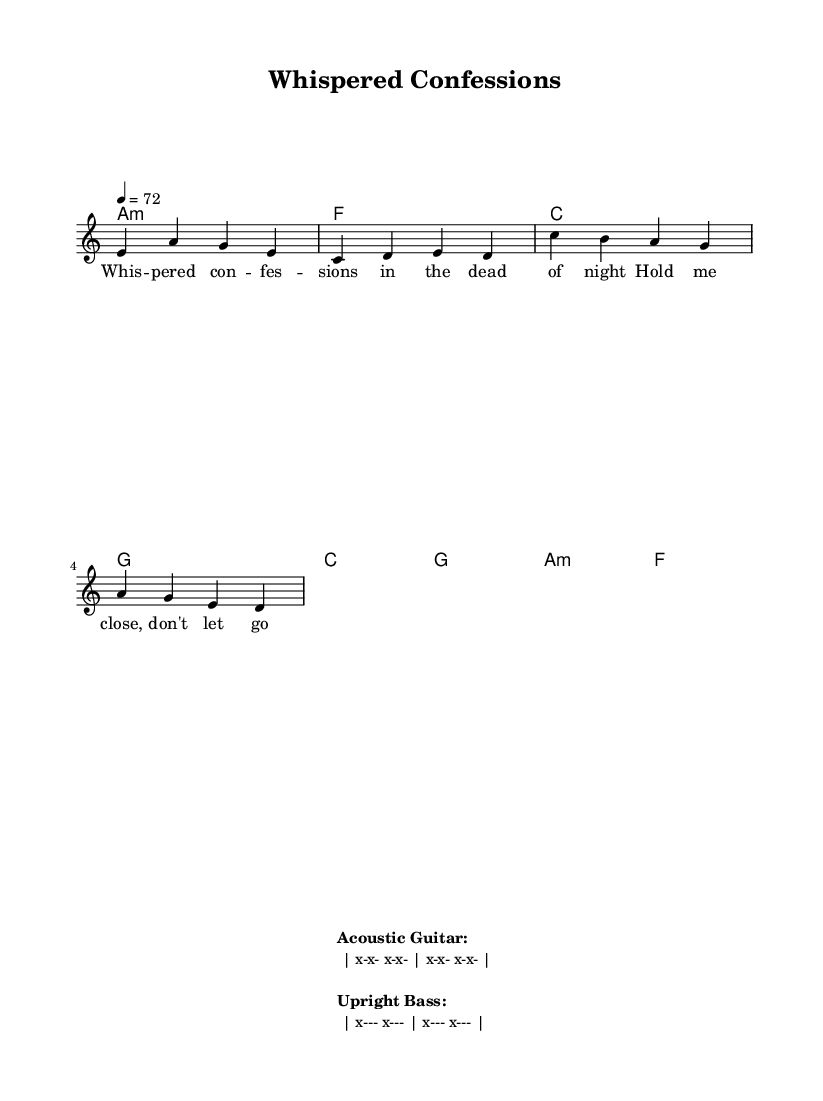What is the key signature of this music? The key signature is A minor, which contains no sharps or flats, as indicated by the key note at the beginning of the score.
Answer: A minor What is the time signature of this piece? The time signature is 4/4, as shown at the beginning of the score, indicating four beats per measure.
Answer: 4/4 What is the tempo marking for this piece? The tempo marking indicates a speed of quarter note equals seventy-two beats per minute, which is noted as "4 = 72" at the beginning of the score.
Answer: 72 How many measures are in the verse section? By counting the measures in the "melody" section labeled as "Verse," there are four distinct measures.
Answer: 4 What instrumentation is featured in this performance? The sheet music specifies the use of acoustic guitar and upright bass through the markings provided at the bottom of the render, indicating minimal accompaniment.
Answer: Acoustic guitar and upright bass What is the mood conveyed by the lyrics of the song? The lyrics "Whispered confessions in the dead of night" suggest an intimate and emotional atmosphere typical of stripped-down R&B performances, reflecting vulnerability and closeness.
Answer: Intimate and emotional How does the use of chords enhance the stripped-down feel? The chord progression used is simple and minimalistic, allowing for greater focus on the melody and the emotional delivery of the lyrics, creating an intimate setting characteristic of R&B.
Answer: Simple and minimalistic 